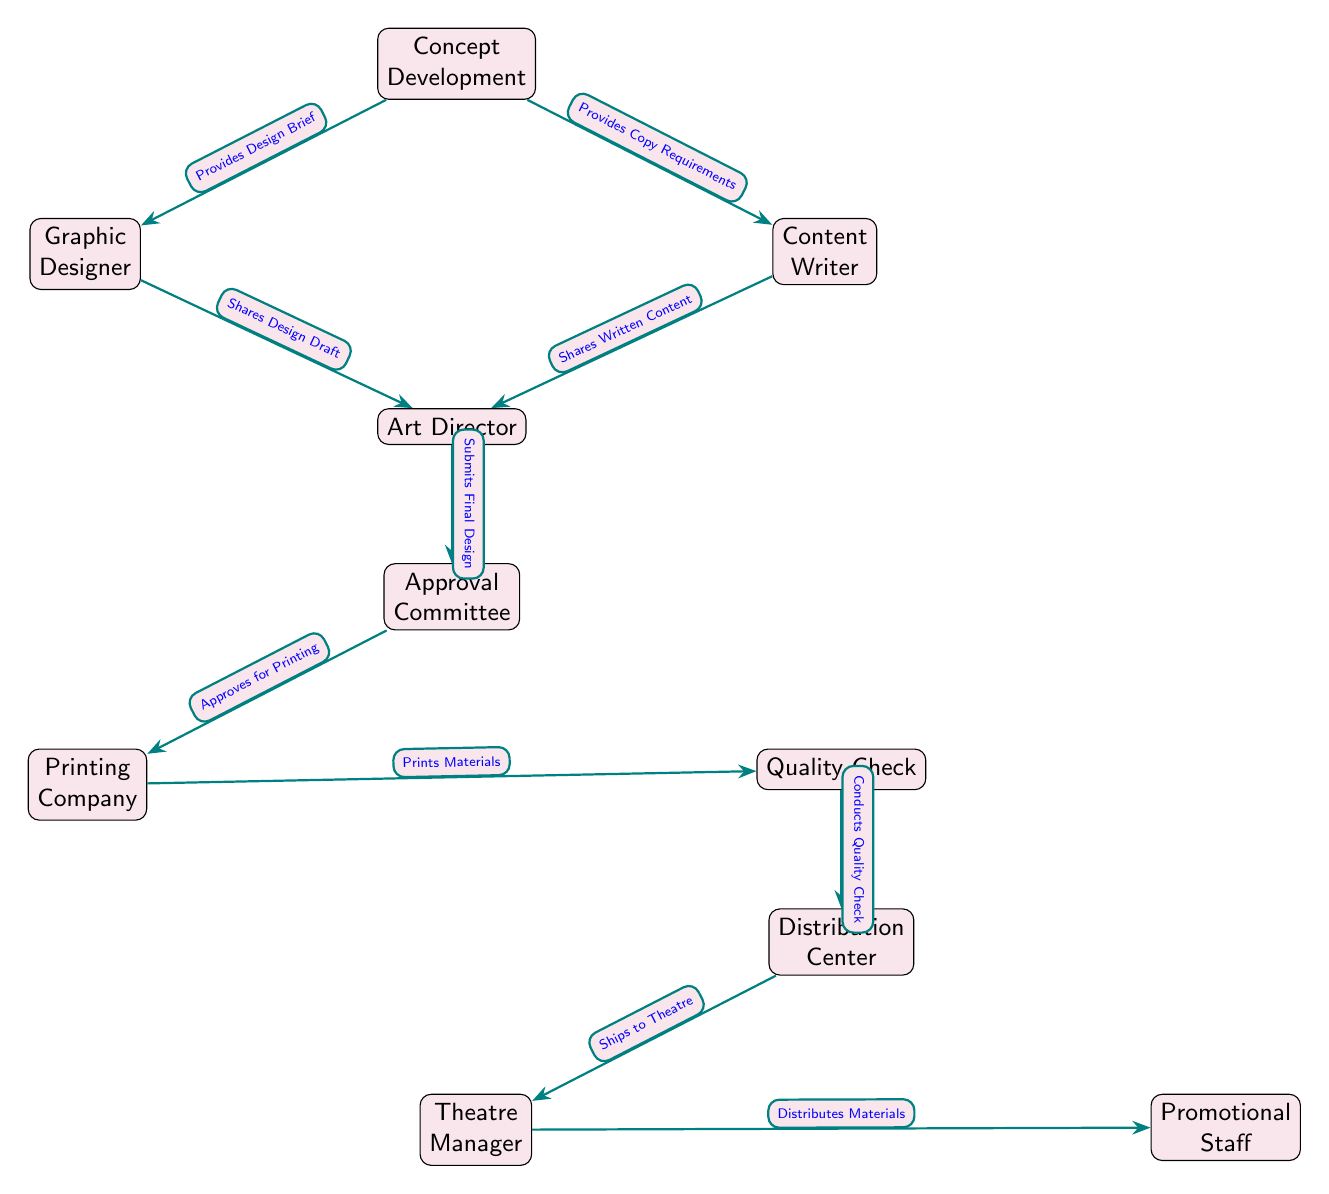What is the first node in the supply chain? The first node indicated in the diagram is "Concept Development," which initiates the entire process of creating promotional materials.
Answer: Concept Development How many nodes are there in total? By counting all the distinct nodes in the diagram, we find that there are ten nodes representing various stages in the supply chain.
Answer: 10 What role does the Graphic Designer play in the process? The Graphic Designer is connected to "Concept Development" and shares a design draft with the Art Director, indicating their function in visual design.
Answer: Shares Design Draft Who approves the final design before printing? According to the flow of the diagram, the final design is submitted to the Approval Committee for their approval, which is a necessary step before moving on to printing.
Answer: Approval Committee What happens after the Quality Check? The flow shows that after conducting a Quality Check, the materials are sent to the Distribution Center, which is responsible for further processing and shipping.
Answer: Ships to Theatre Which node is responsible for distributing the materials? The node labeled "Promotional Staff" is responsible for taking the materials from the Theatre Manager and distributing them as needed for the production.
Answer: Promotional Staff What is the relationship between the Art Director and the Approval Committee? The Art Director submits the final design to the Approval Committee, which reviews and approves it before the materials are printed, indicating a direct line of responsibility and workflow between these two roles.
Answer: Submits Final Design How does the Printing Company fit into the sequence? After the Approval Committee approves the designs, the Printing Company is tasked with printing the materials, highlighting their importance as a production stage following the approval process.
Answer: Prints Materials Which department handles shipping after printing? The diagram illustrates that the Distribution Center is responsible for shipping the materials to the Theatre, thus indicating its logistical role in the supply chain.
Answer: Distribution Center 